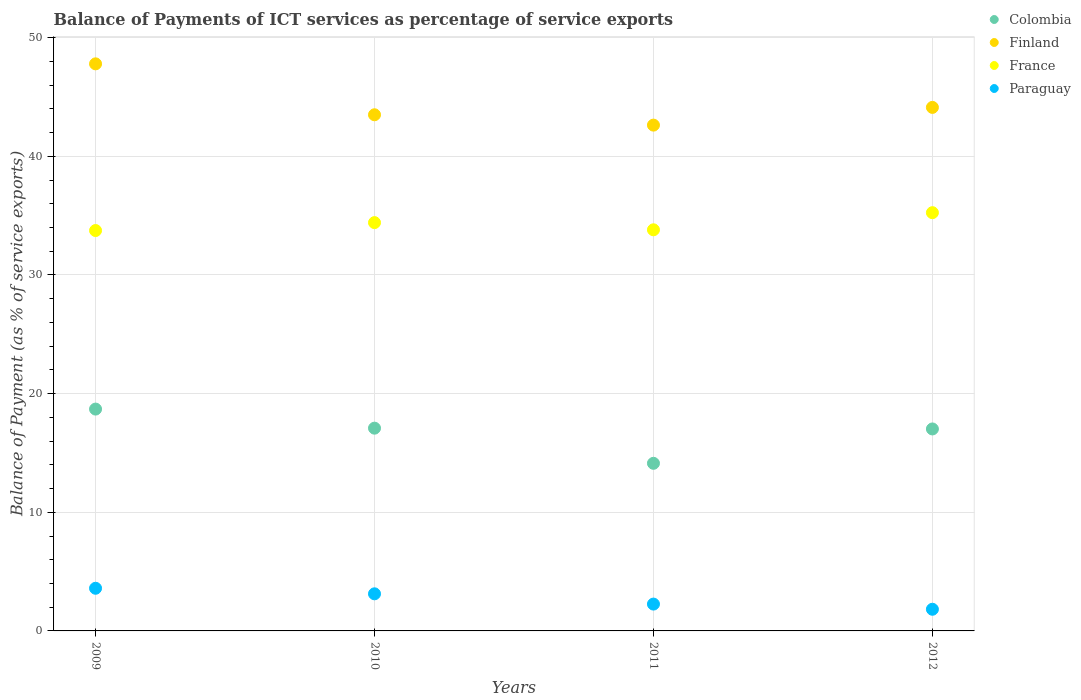Is the number of dotlines equal to the number of legend labels?
Offer a very short reply. Yes. What is the balance of payments of ICT services in Colombia in 2011?
Keep it short and to the point. 14.13. Across all years, what is the maximum balance of payments of ICT services in Colombia?
Give a very brief answer. 18.7. Across all years, what is the minimum balance of payments of ICT services in Finland?
Make the answer very short. 42.63. In which year was the balance of payments of ICT services in Paraguay maximum?
Give a very brief answer. 2009. What is the total balance of payments of ICT services in Finland in the graph?
Offer a very short reply. 178.05. What is the difference between the balance of payments of ICT services in Colombia in 2010 and that in 2011?
Offer a very short reply. 2.96. What is the difference between the balance of payments of ICT services in Colombia in 2011 and the balance of payments of ICT services in Finland in 2009?
Make the answer very short. -33.67. What is the average balance of payments of ICT services in France per year?
Your response must be concise. 34.3. In the year 2011, what is the difference between the balance of payments of ICT services in Finland and balance of payments of ICT services in France?
Your response must be concise. 8.82. In how many years, is the balance of payments of ICT services in Finland greater than 44 %?
Offer a terse response. 2. What is the ratio of the balance of payments of ICT services in Colombia in 2009 to that in 2011?
Your answer should be very brief. 1.32. Is the balance of payments of ICT services in France in 2011 less than that in 2012?
Make the answer very short. Yes. Is the difference between the balance of payments of ICT services in Finland in 2010 and 2012 greater than the difference between the balance of payments of ICT services in France in 2010 and 2012?
Your answer should be compact. Yes. What is the difference between the highest and the second highest balance of payments of ICT services in Finland?
Your response must be concise. 3.67. What is the difference between the highest and the lowest balance of payments of ICT services in Paraguay?
Offer a very short reply. 1.77. Is the balance of payments of ICT services in Finland strictly greater than the balance of payments of ICT services in France over the years?
Give a very brief answer. Yes. Is the balance of payments of ICT services in Paraguay strictly less than the balance of payments of ICT services in Finland over the years?
Make the answer very short. Yes. How many dotlines are there?
Your answer should be compact. 4. How many years are there in the graph?
Provide a short and direct response. 4. What is the difference between two consecutive major ticks on the Y-axis?
Provide a succinct answer. 10. Are the values on the major ticks of Y-axis written in scientific E-notation?
Keep it short and to the point. No. How many legend labels are there?
Keep it short and to the point. 4. How are the legend labels stacked?
Provide a succinct answer. Vertical. What is the title of the graph?
Keep it short and to the point. Balance of Payments of ICT services as percentage of service exports. What is the label or title of the Y-axis?
Make the answer very short. Balance of Payment (as % of service exports). What is the Balance of Payment (as % of service exports) of Colombia in 2009?
Your answer should be very brief. 18.7. What is the Balance of Payment (as % of service exports) in Finland in 2009?
Offer a very short reply. 47.79. What is the Balance of Payment (as % of service exports) in France in 2009?
Provide a succinct answer. 33.75. What is the Balance of Payment (as % of service exports) in Paraguay in 2009?
Give a very brief answer. 3.59. What is the Balance of Payment (as % of service exports) of Colombia in 2010?
Ensure brevity in your answer.  17.09. What is the Balance of Payment (as % of service exports) in Finland in 2010?
Ensure brevity in your answer.  43.5. What is the Balance of Payment (as % of service exports) of France in 2010?
Ensure brevity in your answer.  34.41. What is the Balance of Payment (as % of service exports) of Paraguay in 2010?
Give a very brief answer. 3.13. What is the Balance of Payment (as % of service exports) of Colombia in 2011?
Offer a very short reply. 14.13. What is the Balance of Payment (as % of service exports) in Finland in 2011?
Your answer should be compact. 42.63. What is the Balance of Payment (as % of service exports) of France in 2011?
Offer a very short reply. 33.81. What is the Balance of Payment (as % of service exports) of Paraguay in 2011?
Ensure brevity in your answer.  2.26. What is the Balance of Payment (as % of service exports) in Colombia in 2012?
Provide a short and direct response. 17.02. What is the Balance of Payment (as % of service exports) of Finland in 2012?
Offer a very short reply. 44.12. What is the Balance of Payment (as % of service exports) in France in 2012?
Offer a very short reply. 35.25. What is the Balance of Payment (as % of service exports) of Paraguay in 2012?
Ensure brevity in your answer.  1.83. Across all years, what is the maximum Balance of Payment (as % of service exports) of Colombia?
Make the answer very short. 18.7. Across all years, what is the maximum Balance of Payment (as % of service exports) of Finland?
Provide a short and direct response. 47.79. Across all years, what is the maximum Balance of Payment (as % of service exports) in France?
Provide a succinct answer. 35.25. Across all years, what is the maximum Balance of Payment (as % of service exports) of Paraguay?
Your answer should be compact. 3.59. Across all years, what is the minimum Balance of Payment (as % of service exports) of Colombia?
Your response must be concise. 14.13. Across all years, what is the minimum Balance of Payment (as % of service exports) of Finland?
Give a very brief answer. 42.63. Across all years, what is the minimum Balance of Payment (as % of service exports) in France?
Make the answer very short. 33.75. Across all years, what is the minimum Balance of Payment (as % of service exports) in Paraguay?
Your response must be concise. 1.83. What is the total Balance of Payment (as % of service exports) of Colombia in the graph?
Give a very brief answer. 66.93. What is the total Balance of Payment (as % of service exports) in Finland in the graph?
Your response must be concise. 178.05. What is the total Balance of Payment (as % of service exports) in France in the graph?
Offer a terse response. 137.21. What is the total Balance of Payment (as % of service exports) of Paraguay in the graph?
Your response must be concise. 10.81. What is the difference between the Balance of Payment (as % of service exports) in Colombia in 2009 and that in 2010?
Provide a succinct answer. 1.61. What is the difference between the Balance of Payment (as % of service exports) in Finland in 2009 and that in 2010?
Provide a succinct answer. 4.29. What is the difference between the Balance of Payment (as % of service exports) of France in 2009 and that in 2010?
Provide a succinct answer. -0.67. What is the difference between the Balance of Payment (as % of service exports) of Paraguay in 2009 and that in 2010?
Your response must be concise. 0.47. What is the difference between the Balance of Payment (as % of service exports) in Colombia in 2009 and that in 2011?
Offer a very short reply. 4.57. What is the difference between the Balance of Payment (as % of service exports) of Finland in 2009 and that in 2011?
Your response must be concise. 5.16. What is the difference between the Balance of Payment (as % of service exports) of France in 2009 and that in 2011?
Ensure brevity in your answer.  -0.06. What is the difference between the Balance of Payment (as % of service exports) in Paraguay in 2009 and that in 2011?
Give a very brief answer. 1.33. What is the difference between the Balance of Payment (as % of service exports) of Colombia in 2009 and that in 2012?
Give a very brief answer. 1.67. What is the difference between the Balance of Payment (as % of service exports) of Finland in 2009 and that in 2012?
Ensure brevity in your answer.  3.67. What is the difference between the Balance of Payment (as % of service exports) of France in 2009 and that in 2012?
Offer a terse response. -1.51. What is the difference between the Balance of Payment (as % of service exports) of Paraguay in 2009 and that in 2012?
Give a very brief answer. 1.77. What is the difference between the Balance of Payment (as % of service exports) in Colombia in 2010 and that in 2011?
Make the answer very short. 2.96. What is the difference between the Balance of Payment (as % of service exports) in Finland in 2010 and that in 2011?
Provide a succinct answer. 0.87. What is the difference between the Balance of Payment (as % of service exports) of France in 2010 and that in 2011?
Keep it short and to the point. 0.61. What is the difference between the Balance of Payment (as % of service exports) in Paraguay in 2010 and that in 2011?
Offer a very short reply. 0.87. What is the difference between the Balance of Payment (as % of service exports) of Colombia in 2010 and that in 2012?
Keep it short and to the point. 0.07. What is the difference between the Balance of Payment (as % of service exports) in Finland in 2010 and that in 2012?
Provide a short and direct response. -0.62. What is the difference between the Balance of Payment (as % of service exports) of France in 2010 and that in 2012?
Give a very brief answer. -0.84. What is the difference between the Balance of Payment (as % of service exports) in Paraguay in 2010 and that in 2012?
Give a very brief answer. 1.3. What is the difference between the Balance of Payment (as % of service exports) in Colombia in 2011 and that in 2012?
Give a very brief answer. -2.9. What is the difference between the Balance of Payment (as % of service exports) in Finland in 2011 and that in 2012?
Your answer should be very brief. -1.49. What is the difference between the Balance of Payment (as % of service exports) in France in 2011 and that in 2012?
Make the answer very short. -1.44. What is the difference between the Balance of Payment (as % of service exports) in Paraguay in 2011 and that in 2012?
Ensure brevity in your answer.  0.44. What is the difference between the Balance of Payment (as % of service exports) of Colombia in 2009 and the Balance of Payment (as % of service exports) of Finland in 2010?
Offer a terse response. -24.81. What is the difference between the Balance of Payment (as % of service exports) in Colombia in 2009 and the Balance of Payment (as % of service exports) in France in 2010?
Make the answer very short. -15.72. What is the difference between the Balance of Payment (as % of service exports) of Colombia in 2009 and the Balance of Payment (as % of service exports) of Paraguay in 2010?
Provide a succinct answer. 15.57. What is the difference between the Balance of Payment (as % of service exports) in Finland in 2009 and the Balance of Payment (as % of service exports) in France in 2010?
Your answer should be compact. 13.38. What is the difference between the Balance of Payment (as % of service exports) in Finland in 2009 and the Balance of Payment (as % of service exports) in Paraguay in 2010?
Provide a succinct answer. 44.67. What is the difference between the Balance of Payment (as % of service exports) of France in 2009 and the Balance of Payment (as % of service exports) of Paraguay in 2010?
Ensure brevity in your answer.  30.62. What is the difference between the Balance of Payment (as % of service exports) of Colombia in 2009 and the Balance of Payment (as % of service exports) of Finland in 2011?
Give a very brief answer. -23.93. What is the difference between the Balance of Payment (as % of service exports) of Colombia in 2009 and the Balance of Payment (as % of service exports) of France in 2011?
Your answer should be very brief. -15.11. What is the difference between the Balance of Payment (as % of service exports) in Colombia in 2009 and the Balance of Payment (as % of service exports) in Paraguay in 2011?
Ensure brevity in your answer.  16.44. What is the difference between the Balance of Payment (as % of service exports) of Finland in 2009 and the Balance of Payment (as % of service exports) of France in 2011?
Offer a very short reply. 13.99. What is the difference between the Balance of Payment (as % of service exports) of Finland in 2009 and the Balance of Payment (as % of service exports) of Paraguay in 2011?
Give a very brief answer. 45.53. What is the difference between the Balance of Payment (as % of service exports) in France in 2009 and the Balance of Payment (as % of service exports) in Paraguay in 2011?
Ensure brevity in your answer.  31.48. What is the difference between the Balance of Payment (as % of service exports) in Colombia in 2009 and the Balance of Payment (as % of service exports) in Finland in 2012?
Give a very brief answer. -25.43. What is the difference between the Balance of Payment (as % of service exports) in Colombia in 2009 and the Balance of Payment (as % of service exports) in France in 2012?
Your response must be concise. -16.55. What is the difference between the Balance of Payment (as % of service exports) in Colombia in 2009 and the Balance of Payment (as % of service exports) in Paraguay in 2012?
Ensure brevity in your answer.  16.87. What is the difference between the Balance of Payment (as % of service exports) in Finland in 2009 and the Balance of Payment (as % of service exports) in France in 2012?
Your answer should be compact. 12.54. What is the difference between the Balance of Payment (as % of service exports) in Finland in 2009 and the Balance of Payment (as % of service exports) in Paraguay in 2012?
Offer a very short reply. 45.97. What is the difference between the Balance of Payment (as % of service exports) in France in 2009 and the Balance of Payment (as % of service exports) in Paraguay in 2012?
Give a very brief answer. 31.92. What is the difference between the Balance of Payment (as % of service exports) of Colombia in 2010 and the Balance of Payment (as % of service exports) of Finland in 2011?
Your answer should be very brief. -25.54. What is the difference between the Balance of Payment (as % of service exports) in Colombia in 2010 and the Balance of Payment (as % of service exports) in France in 2011?
Give a very brief answer. -16.72. What is the difference between the Balance of Payment (as % of service exports) in Colombia in 2010 and the Balance of Payment (as % of service exports) in Paraguay in 2011?
Ensure brevity in your answer.  14.83. What is the difference between the Balance of Payment (as % of service exports) in Finland in 2010 and the Balance of Payment (as % of service exports) in France in 2011?
Offer a very short reply. 9.7. What is the difference between the Balance of Payment (as % of service exports) of Finland in 2010 and the Balance of Payment (as % of service exports) of Paraguay in 2011?
Your answer should be compact. 41.24. What is the difference between the Balance of Payment (as % of service exports) in France in 2010 and the Balance of Payment (as % of service exports) in Paraguay in 2011?
Keep it short and to the point. 32.15. What is the difference between the Balance of Payment (as % of service exports) of Colombia in 2010 and the Balance of Payment (as % of service exports) of Finland in 2012?
Give a very brief answer. -27.04. What is the difference between the Balance of Payment (as % of service exports) in Colombia in 2010 and the Balance of Payment (as % of service exports) in France in 2012?
Provide a short and direct response. -18.16. What is the difference between the Balance of Payment (as % of service exports) of Colombia in 2010 and the Balance of Payment (as % of service exports) of Paraguay in 2012?
Your response must be concise. 15.26. What is the difference between the Balance of Payment (as % of service exports) of Finland in 2010 and the Balance of Payment (as % of service exports) of France in 2012?
Your response must be concise. 8.25. What is the difference between the Balance of Payment (as % of service exports) in Finland in 2010 and the Balance of Payment (as % of service exports) in Paraguay in 2012?
Your answer should be very brief. 41.68. What is the difference between the Balance of Payment (as % of service exports) in France in 2010 and the Balance of Payment (as % of service exports) in Paraguay in 2012?
Your answer should be very brief. 32.59. What is the difference between the Balance of Payment (as % of service exports) of Colombia in 2011 and the Balance of Payment (as % of service exports) of Finland in 2012?
Your answer should be very brief. -30. What is the difference between the Balance of Payment (as % of service exports) of Colombia in 2011 and the Balance of Payment (as % of service exports) of France in 2012?
Provide a succinct answer. -21.12. What is the difference between the Balance of Payment (as % of service exports) in Colombia in 2011 and the Balance of Payment (as % of service exports) in Paraguay in 2012?
Offer a very short reply. 12.3. What is the difference between the Balance of Payment (as % of service exports) in Finland in 2011 and the Balance of Payment (as % of service exports) in France in 2012?
Provide a short and direct response. 7.38. What is the difference between the Balance of Payment (as % of service exports) in Finland in 2011 and the Balance of Payment (as % of service exports) in Paraguay in 2012?
Keep it short and to the point. 40.8. What is the difference between the Balance of Payment (as % of service exports) of France in 2011 and the Balance of Payment (as % of service exports) of Paraguay in 2012?
Your response must be concise. 31.98. What is the average Balance of Payment (as % of service exports) of Colombia per year?
Provide a short and direct response. 16.73. What is the average Balance of Payment (as % of service exports) of Finland per year?
Offer a very short reply. 44.51. What is the average Balance of Payment (as % of service exports) of France per year?
Your response must be concise. 34.3. What is the average Balance of Payment (as % of service exports) of Paraguay per year?
Your answer should be very brief. 2.7. In the year 2009, what is the difference between the Balance of Payment (as % of service exports) in Colombia and Balance of Payment (as % of service exports) in Finland?
Ensure brevity in your answer.  -29.1. In the year 2009, what is the difference between the Balance of Payment (as % of service exports) in Colombia and Balance of Payment (as % of service exports) in France?
Provide a short and direct response. -15.05. In the year 2009, what is the difference between the Balance of Payment (as % of service exports) in Colombia and Balance of Payment (as % of service exports) in Paraguay?
Keep it short and to the point. 15.1. In the year 2009, what is the difference between the Balance of Payment (as % of service exports) in Finland and Balance of Payment (as % of service exports) in France?
Provide a succinct answer. 14.05. In the year 2009, what is the difference between the Balance of Payment (as % of service exports) in Finland and Balance of Payment (as % of service exports) in Paraguay?
Ensure brevity in your answer.  44.2. In the year 2009, what is the difference between the Balance of Payment (as % of service exports) of France and Balance of Payment (as % of service exports) of Paraguay?
Your answer should be compact. 30.15. In the year 2010, what is the difference between the Balance of Payment (as % of service exports) in Colombia and Balance of Payment (as % of service exports) in Finland?
Offer a terse response. -26.41. In the year 2010, what is the difference between the Balance of Payment (as % of service exports) of Colombia and Balance of Payment (as % of service exports) of France?
Offer a very short reply. -17.32. In the year 2010, what is the difference between the Balance of Payment (as % of service exports) in Colombia and Balance of Payment (as % of service exports) in Paraguay?
Offer a very short reply. 13.96. In the year 2010, what is the difference between the Balance of Payment (as % of service exports) in Finland and Balance of Payment (as % of service exports) in France?
Provide a short and direct response. 9.09. In the year 2010, what is the difference between the Balance of Payment (as % of service exports) in Finland and Balance of Payment (as % of service exports) in Paraguay?
Your response must be concise. 40.37. In the year 2010, what is the difference between the Balance of Payment (as % of service exports) of France and Balance of Payment (as % of service exports) of Paraguay?
Offer a terse response. 31.28. In the year 2011, what is the difference between the Balance of Payment (as % of service exports) in Colombia and Balance of Payment (as % of service exports) in Finland?
Your answer should be very brief. -28.5. In the year 2011, what is the difference between the Balance of Payment (as % of service exports) of Colombia and Balance of Payment (as % of service exports) of France?
Your answer should be very brief. -19.68. In the year 2011, what is the difference between the Balance of Payment (as % of service exports) of Colombia and Balance of Payment (as % of service exports) of Paraguay?
Your response must be concise. 11.87. In the year 2011, what is the difference between the Balance of Payment (as % of service exports) of Finland and Balance of Payment (as % of service exports) of France?
Keep it short and to the point. 8.82. In the year 2011, what is the difference between the Balance of Payment (as % of service exports) in Finland and Balance of Payment (as % of service exports) in Paraguay?
Provide a succinct answer. 40.37. In the year 2011, what is the difference between the Balance of Payment (as % of service exports) of France and Balance of Payment (as % of service exports) of Paraguay?
Provide a short and direct response. 31.55. In the year 2012, what is the difference between the Balance of Payment (as % of service exports) of Colombia and Balance of Payment (as % of service exports) of Finland?
Offer a terse response. -27.1. In the year 2012, what is the difference between the Balance of Payment (as % of service exports) of Colombia and Balance of Payment (as % of service exports) of France?
Provide a short and direct response. -18.23. In the year 2012, what is the difference between the Balance of Payment (as % of service exports) in Colombia and Balance of Payment (as % of service exports) in Paraguay?
Ensure brevity in your answer.  15.2. In the year 2012, what is the difference between the Balance of Payment (as % of service exports) of Finland and Balance of Payment (as % of service exports) of France?
Your answer should be compact. 8.87. In the year 2012, what is the difference between the Balance of Payment (as % of service exports) of Finland and Balance of Payment (as % of service exports) of Paraguay?
Your response must be concise. 42.3. In the year 2012, what is the difference between the Balance of Payment (as % of service exports) of France and Balance of Payment (as % of service exports) of Paraguay?
Your answer should be very brief. 33.42. What is the ratio of the Balance of Payment (as % of service exports) of Colombia in 2009 to that in 2010?
Offer a terse response. 1.09. What is the ratio of the Balance of Payment (as % of service exports) of Finland in 2009 to that in 2010?
Offer a very short reply. 1.1. What is the ratio of the Balance of Payment (as % of service exports) of France in 2009 to that in 2010?
Your answer should be very brief. 0.98. What is the ratio of the Balance of Payment (as % of service exports) in Paraguay in 2009 to that in 2010?
Offer a very short reply. 1.15. What is the ratio of the Balance of Payment (as % of service exports) of Colombia in 2009 to that in 2011?
Your answer should be compact. 1.32. What is the ratio of the Balance of Payment (as % of service exports) of Finland in 2009 to that in 2011?
Give a very brief answer. 1.12. What is the ratio of the Balance of Payment (as % of service exports) in France in 2009 to that in 2011?
Make the answer very short. 1. What is the ratio of the Balance of Payment (as % of service exports) of Paraguay in 2009 to that in 2011?
Ensure brevity in your answer.  1.59. What is the ratio of the Balance of Payment (as % of service exports) in Colombia in 2009 to that in 2012?
Ensure brevity in your answer.  1.1. What is the ratio of the Balance of Payment (as % of service exports) in Finland in 2009 to that in 2012?
Offer a very short reply. 1.08. What is the ratio of the Balance of Payment (as % of service exports) in France in 2009 to that in 2012?
Your answer should be very brief. 0.96. What is the ratio of the Balance of Payment (as % of service exports) in Paraguay in 2009 to that in 2012?
Keep it short and to the point. 1.97. What is the ratio of the Balance of Payment (as % of service exports) in Colombia in 2010 to that in 2011?
Provide a succinct answer. 1.21. What is the ratio of the Balance of Payment (as % of service exports) of Finland in 2010 to that in 2011?
Your answer should be very brief. 1.02. What is the ratio of the Balance of Payment (as % of service exports) in France in 2010 to that in 2011?
Your answer should be very brief. 1.02. What is the ratio of the Balance of Payment (as % of service exports) of Paraguay in 2010 to that in 2011?
Keep it short and to the point. 1.38. What is the ratio of the Balance of Payment (as % of service exports) in Finland in 2010 to that in 2012?
Give a very brief answer. 0.99. What is the ratio of the Balance of Payment (as % of service exports) in France in 2010 to that in 2012?
Your answer should be compact. 0.98. What is the ratio of the Balance of Payment (as % of service exports) of Paraguay in 2010 to that in 2012?
Make the answer very short. 1.71. What is the ratio of the Balance of Payment (as % of service exports) of Colombia in 2011 to that in 2012?
Your answer should be compact. 0.83. What is the ratio of the Balance of Payment (as % of service exports) in Finland in 2011 to that in 2012?
Offer a terse response. 0.97. What is the ratio of the Balance of Payment (as % of service exports) of France in 2011 to that in 2012?
Keep it short and to the point. 0.96. What is the ratio of the Balance of Payment (as % of service exports) in Paraguay in 2011 to that in 2012?
Provide a short and direct response. 1.24. What is the difference between the highest and the second highest Balance of Payment (as % of service exports) in Colombia?
Offer a very short reply. 1.61. What is the difference between the highest and the second highest Balance of Payment (as % of service exports) of Finland?
Your answer should be compact. 3.67. What is the difference between the highest and the second highest Balance of Payment (as % of service exports) of France?
Keep it short and to the point. 0.84. What is the difference between the highest and the second highest Balance of Payment (as % of service exports) of Paraguay?
Your answer should be compact. 0.47. What is the difference between the highest and the lowest Balance of Payment (as % of service exports) of Colombia?
Provide a succinct answer. 4.57. What is the difference between the highest and the lowest Balance of Payment (as % of service exports) in Finland?
Provide a succinct answer. 5.16. What is the difference between the highest and the lowest Balance of Payment (as % of service exports) of France?
Provide a succinct answer. 1.51. What is the difference between the highest and the lowest Balance of Payment (as % of service exports) of Paraguay?
Ensure brevity in your answer.  1.77. 